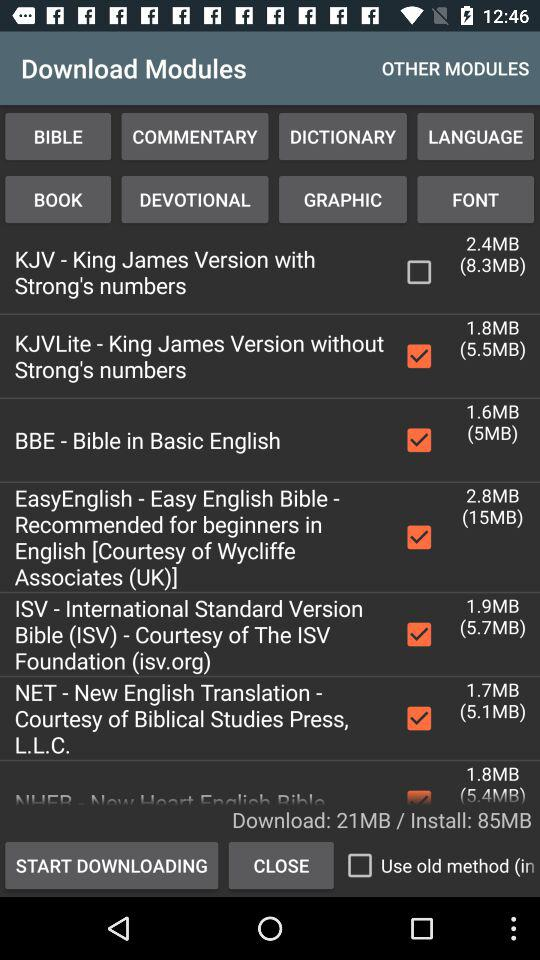How much is the MB of BBE?
When the provided information is insufficient, respond with <no answer>. <no answer> 